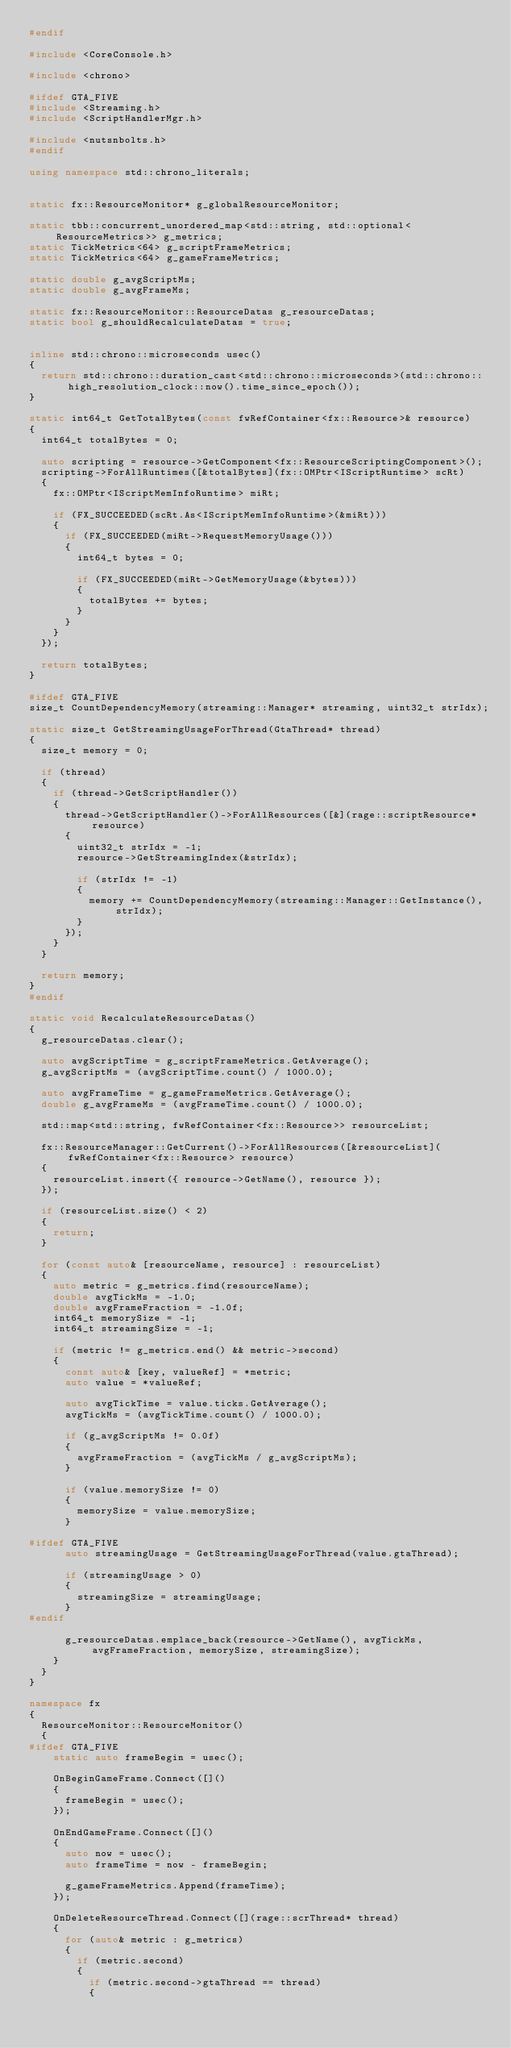<code> <loc_0><loc_0><loc_500><loc_500><_C++_>#endif

#include <CoreConsole.h>

#include <chrono>

#ifdef GTA_FIVE
#include <Streaming.h>
#include <ScriptHandlerMgr.h>

#include <nutsnbolts.h>
#endif

using namespace std::chrono_literals;


static fx::ResourceMonitor* g_globalResourceMonitor;

static tbb::concurrent_unordered_map<std::string, std::optional<ResourceMetrics>> g_metrics;
static TickMetrics<64> g_scriptFrameMetrics;
static TickMetrics<64> g_gameFrameMetrics;

static double g_avgScriptMs;
static double g_avgFrameMs;

static fx::ResourceMonitor::ResourceDatas g_resourceDatas;
static bool g_shouldRecalculateDatas = true;


inline std::chrono::microseconds usec()
{
	return std::chrono::duration_cast<std::chrono::microseconds>(std::chrono::high_resolution_clock::now().time_since_epoch());
}

static int64_t GetTotalBytes(const fwRefContainer<fx::Resource>& resource)
{
	int64_t totalBytes = 0;

	auto scripting = resource->GetComponent<fx::ResourceScriptingComponent>();
	scripting->ForAllRuntimes([&totalBytes](fx::OMPtr<IScriptRuntime> scRt)
	{
		fx::OMPtr<IScriptMemInfoRuntime> miRt;

		if (FX_SUCCEEDED(scRt.As<IScriptMemInfoRuntime>(&miRt)))
		{
			if (FX_SUCCEEDED(miRt->RequestMemoryUsage()))
			{
				int64_t bytes = 0;

				if (FX_SUCCEEDED(miRt->GetMemoryUsage(&bytes)))
				{
					totalBytes += bytes;
				}
			}
		}
	});

	return totalBytes;
}

#ifdef GTA_FIVE
size_t CountDependencyMemory(streaming::Manager* streaming, uint32_t strIdx);

static size_t GetStreamingUsageForThread(GtaThread* thread)
{
	size_t memory = 0;

	if (thread)
	{
		if (thread->GetScriptHandler())
		{
			thread->GetScriptHandler()->ForAllResources([&](rage::scriptResource* resource)
			{
				uint32_t strIdx = -1;
				resource->GetStreamingIndex(&strIdx);

				if (strIdx != -1)
				{
					memory += CountDependencyMemory(streaming::Manager::GetInstance(), strIdx);
				}
			});
		}
	}

	return memory;
}
#endif

static void RecalculateResourceDatas()
{
	g_resourceDatas.clear();

	auto avgScriptTime = g_scriptFrameMetrics.GetAverage();
	g_avgScriptMs = (avgScriptTime.count() / 1000.0);

	auto avgFrameTime = g_gameFrameMetrics.GetAverage();
	double g_avgFrameMs = (avgFrameTime.count() / 1000.0);

	std::map<std::string, fwRefContainer<fx::Resource>> resourceList;

	fx::ResourceManager::GetCurrent()->ForAllResources([&resourceList](fwRefContainer<fx::Resource> resource)
	{
		resourceList.insert({ resource->GetName(), resource });
	});

	if (resourceList.size() < 2)
	{
		return;
	}

	for (const auto& [resourceName, resource] : resourceList)
	{
		auto metric = g_metrics.find(resourceName);
		double avgTickMs = -1.0;
		double avgFrameFraction = -1.0f;
		int64_t memorySize = -1;
		int64_t streamingSize = -1;

		if (metric != g_metrics.end() && metric->second)
		{
			const auto& [key, valueRef] = *metric;
			auto value = *valueRef;

			auto avgTickTime = value.ticks.GetAverage();
			avgTickMs = (avgTickTime.count() / 1000.0);

			if (g_avgScriptMs != 0.0f)
			{
				avgFrameFraction = (avgTickMs / g_avgScriptMs);
			}

			if (value.memorySize != 0)
			{
				memorySize = value.memorySize;
			}

#ifdef GTA_FIVE
			auto streamingUsage = GetStreamingUsageForThread(value.gtaThread);

			if (streamingUsage > 0)
			{
				streamingSize = streamingUsage;
			}
#endif

			g_resourceDatas.emplace_back(resource->GetName(), avgTickMs, avgFrameFraction, memorySize, streamingSize);
		}
	}
}

namespace fx
{
	ResourceMonitor::ResourceMonitor()
	{
#ifdef GTA_FIVE
		static auto frameBegin = usec();

		OnBeginGameFrame.Connect([]()
		{
			frameBegin = usec();
		});

		OnEndGameFrame.Connect([]()
		{
			auto now = usec();
			auto frameTime = now - frameBegin;

			g_gameFrameMetrics.Append(frameTime);
		});

		OnDeleteResourceThread.Connect([](rage::scrThread* thread)
		{
			for (auto& metric : g_metrics)
			{
				if (metric.second)
				{
					if (metric.second->gtaThread == thread)
					{</code> 